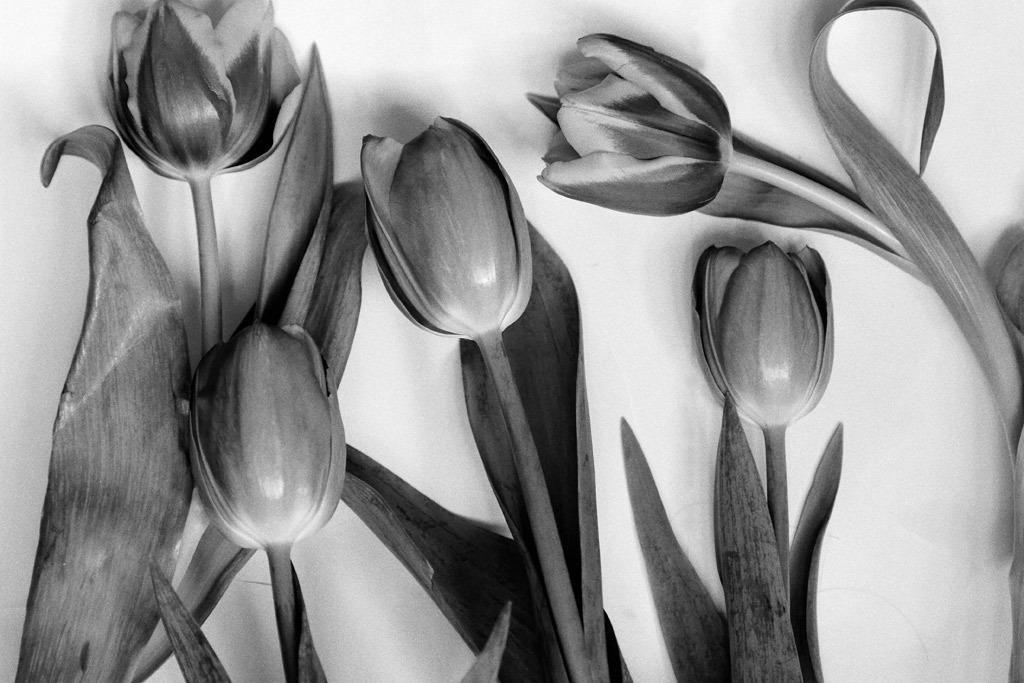What is the color scheme of the image? The image is black and white. What type of flowers are in the image? There are lotuses in the image. What is the background or surface on which the lotuses are placed? The lotuses are on a white surface. Can you tell me how many turkeys are visible in the image? There are no turkeys present in the image; it features lotuses on a white surface. What type of spoon is used to serve the lotuses in the image? There is no spoon present in the image, as it only features lotuses on a white surface. 